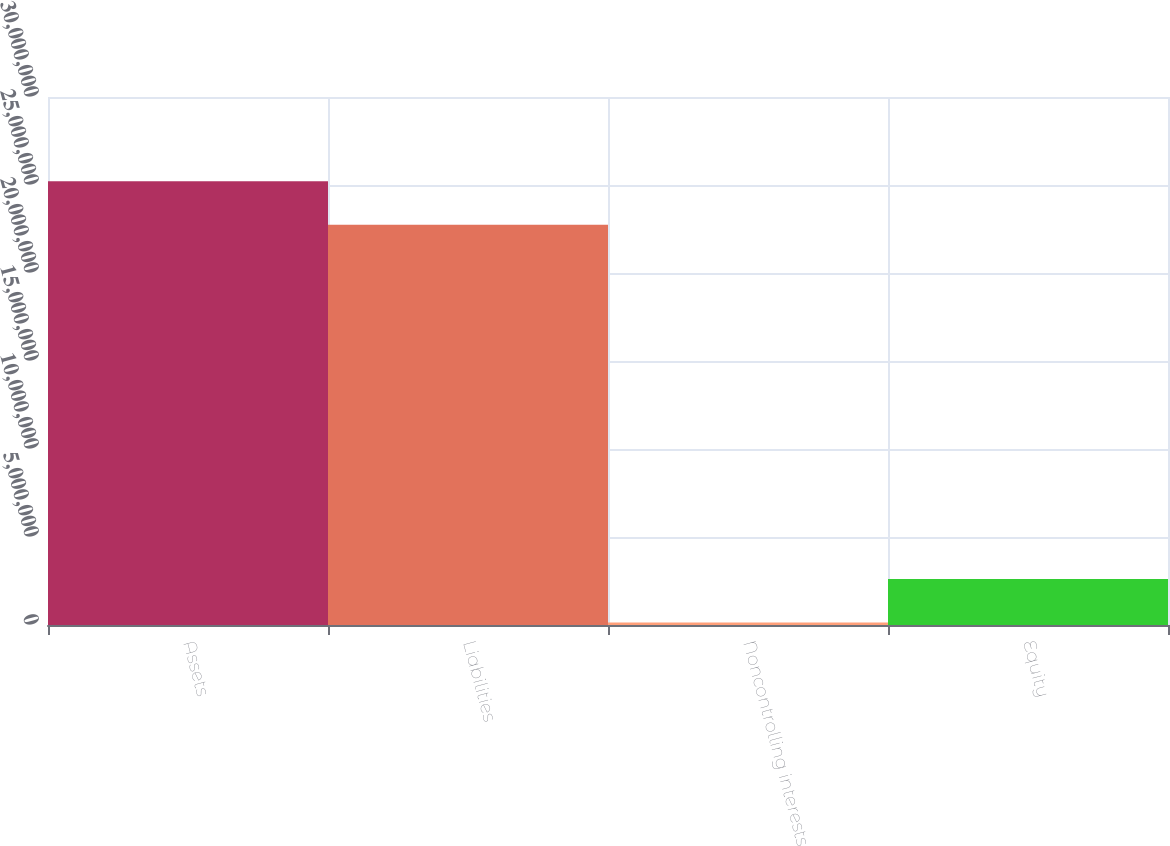<chart> <loc_0><loc_0><loc_500><loc_500><bar_chart><fcel>Assets<fcel>Liabilities<fcel>Noncontrolling interests<fcel>Equity<nl><fcel>2.52062e+07<fcel>2.2739e+07<fcel>140000<fcel>2.6072e+06<nl></chart> 